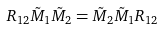<formula> <loc_0><loc_0><loc_500><loc_500>R _ { 1 2 } \tilde { M } _ { 1 } \tilde { M } _ { 2 } = \tilde { M } _ { 2 } \tilde { M } _ { 1 } R _ { 1 2 }</formula> 